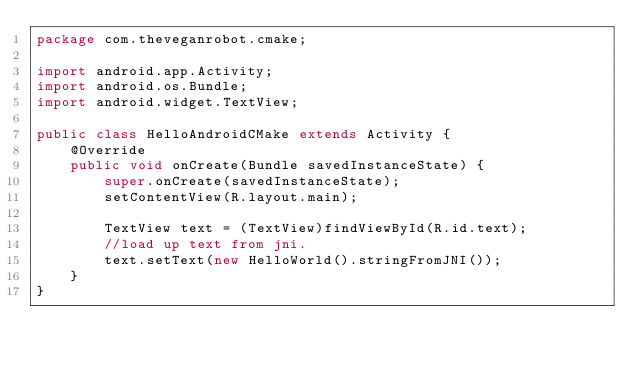<code> <loc_0><loc_0><loc_500><loc_500><_Java_>package com.theveganrobot.cmake;

import android.app.Activity;
import android.os.Bundle;
import android.widget.TextView;

public class HelloAndroidCMake extends Activity {
    @Override
    public void onCreate(Bundle savedInstanceState) {
        super.onCreate(savedInstanceState);
        setContentView(R.layout.main);
        
        TextView text = (TextView)findViewById(R.id.text);
        //load up text from jni.
        text.setText(new HelloWorld().stringFromJNI());
    }
}</code> 